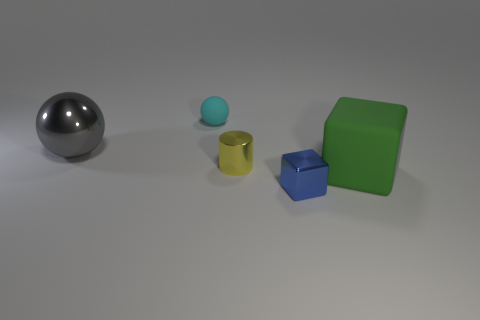Add 4 small blue shiny spheres. How many objects exist? 9 Subtract all cylinders. How many objects are left? 4 Add 4 gray balls. How many gray balls exist? 5 Subtract 1 blue blocks. How many objects are left? 4 Subtract all tiny cyan spheres. Subtract all big brown rubber things. How many objects are left? 4 Add 4 cyan objects. How many cyan objects are left? 5 